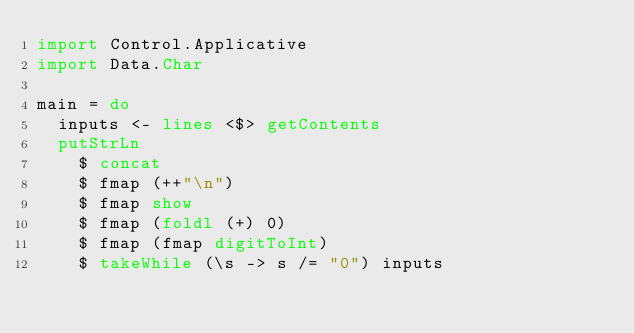<code> <loc_0><loc_0><loc_500><loc_500><_Haskell_>import Control.Applicative
import Data.Char

main = do
  inputs <- lines <$> getContents
  putStrLn
    $ concat
    $ fmap (++"\n")
    $ fmap show
    $ fmap (foldl (+) 0)
    $ fmap (fmap digitToInt)
    $ takeWhile (\s -> s /= "0") inputs</code> 